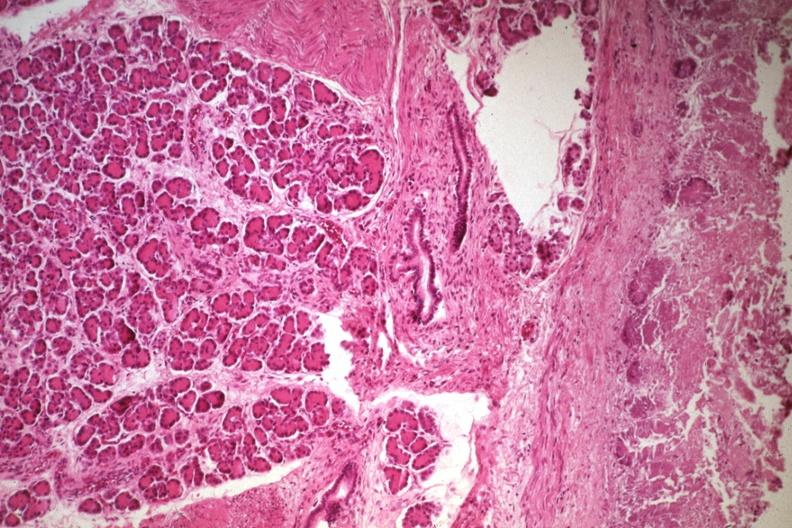s no cystic aortic lesions present?
Answer the question using a single word or phrase. No 